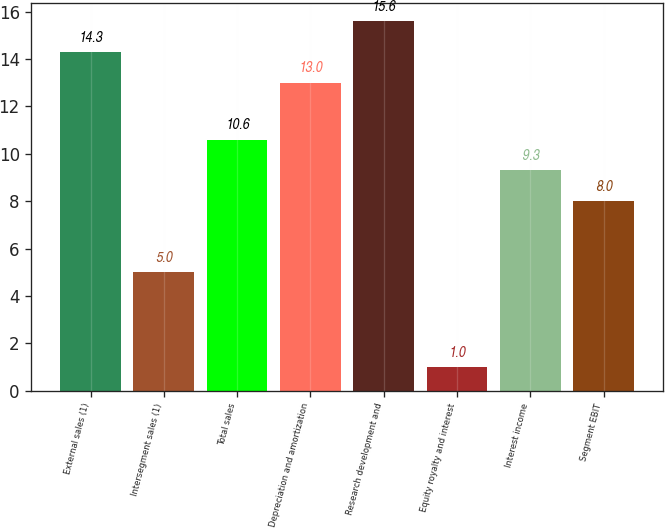<chart> <loc_0><loc_0><loc_500><loc_500><bar_chart><fcel>External sales (1)<fcel>Intersegment sales (1)<fcel>Total sales<fcel>Depreciation and amortization<fcel>Research development and<fcel>Equity royalty and interest<fcel>Interest income<fcel>Segment EBIT<nl><fcel>14.3<fcel>5<fcel>10.6<fcel>13<fcel>15.6<fcel>1<fcel>9.3<fcel>8<nl></chart> 